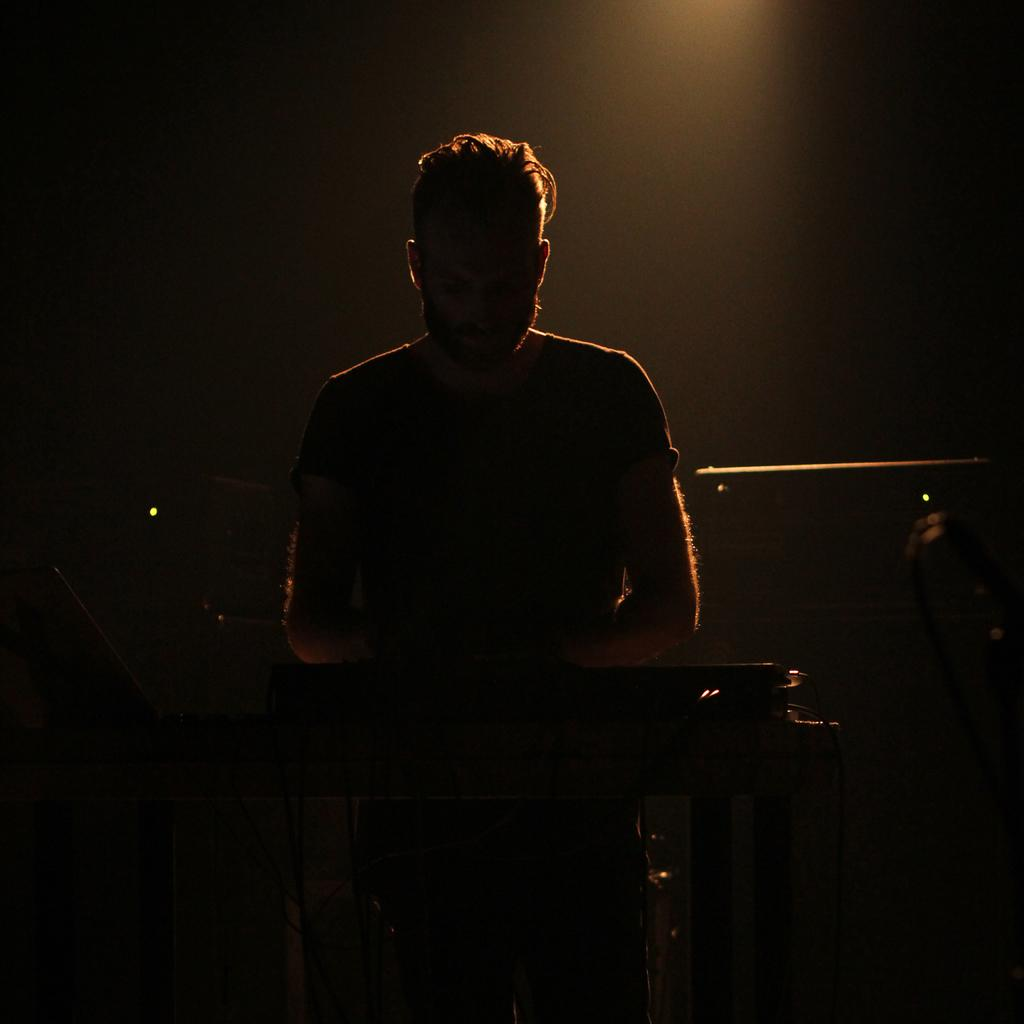What is the main subject of the image? There is a man standing in the image. What is the man wearing? The man is wearing clothes. What object is in front of the man? There is a musical instrument in front of the man. Can you describe any other elements in the image? There is a cable wire in the image. What type of jeans is the man wearing in the image? The provided facts do not mention the type of jeans the man is wearing, so we cannot determine that information from the image. --- Facts: 1. There is a car in the image. 2. The car is red. 3. The car has four wheels. 4. There is a road in the image. 5. The road is paved. Absurd Topics: parrot, sand, dance Conversation: What is the main subject of the image? There is a car in the image. What color is the car? The car is red. How many wheels does the car have? The car has four wheels. What is the surface of the road in the image? The road is paved. Reasoning: Let's think step by step in order to produce the conversation. We start by identifying the main subject of the image, which is the car. Then, we describe the color and number of wheels of the car to provide more details about its appearance. Next, we mention the road in the image and describe its surface to give a sense of the environment. Absurd Question/Answer: Can you tell me how many parrots are sitting on the car in the image? There are no parrots present in the image; it only features a red car with four wheels on a paved road. --- Facts: 1. There is a group of people in the image. 2. The people are wearing hats. 3. The people are holding hands. 4. There is a tree in the background of the image. 5. The sky is visible in the image. Absurd Topics: bicycle, rain, mountain Conversation: What is the main subject of the image? There is a group of people in the image. What are the people wearing? The people are wearing hats. What are the people doing in the image? The people are holding hands. What can be seen in the background of the image? There is a tree in the background of the image. What is visible at the top of the image? The sky is visible in the image. Reasoning: Let's think step by step in order to produce the conversation. We start by identifying the main subject of the image, which is the group of people. Then, we describe what the people are wearing to provide more context about their appearance. Next, we 